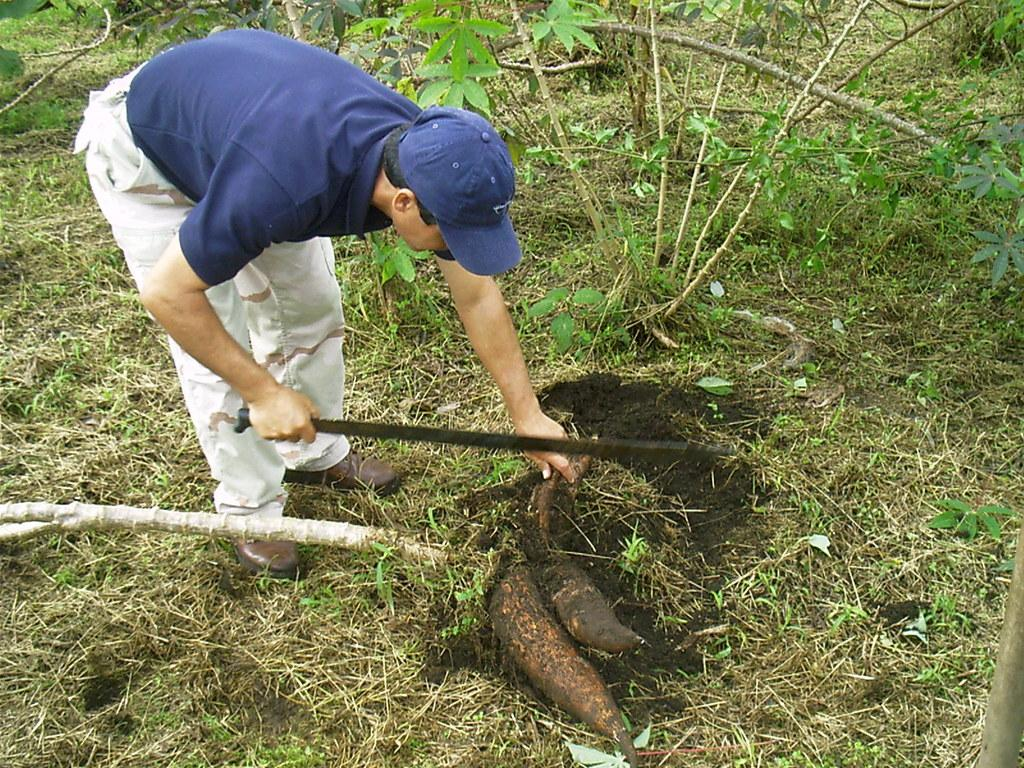Who is present in the image? There is a man in the image. Where is the man located in the image? The man is on the left side of the image. What is the man doing in the image? The man is digging the floor. What can be seen in the background of the image? There is greenery around the area of the image. What type of toys can be seen scattered around the man in the image? There are no toys present in the image; the man is digging the floor. What color is the yarn that the man is using to dig the floor? There is no yarn present in the image; the man is using a tool to dig the floor. 